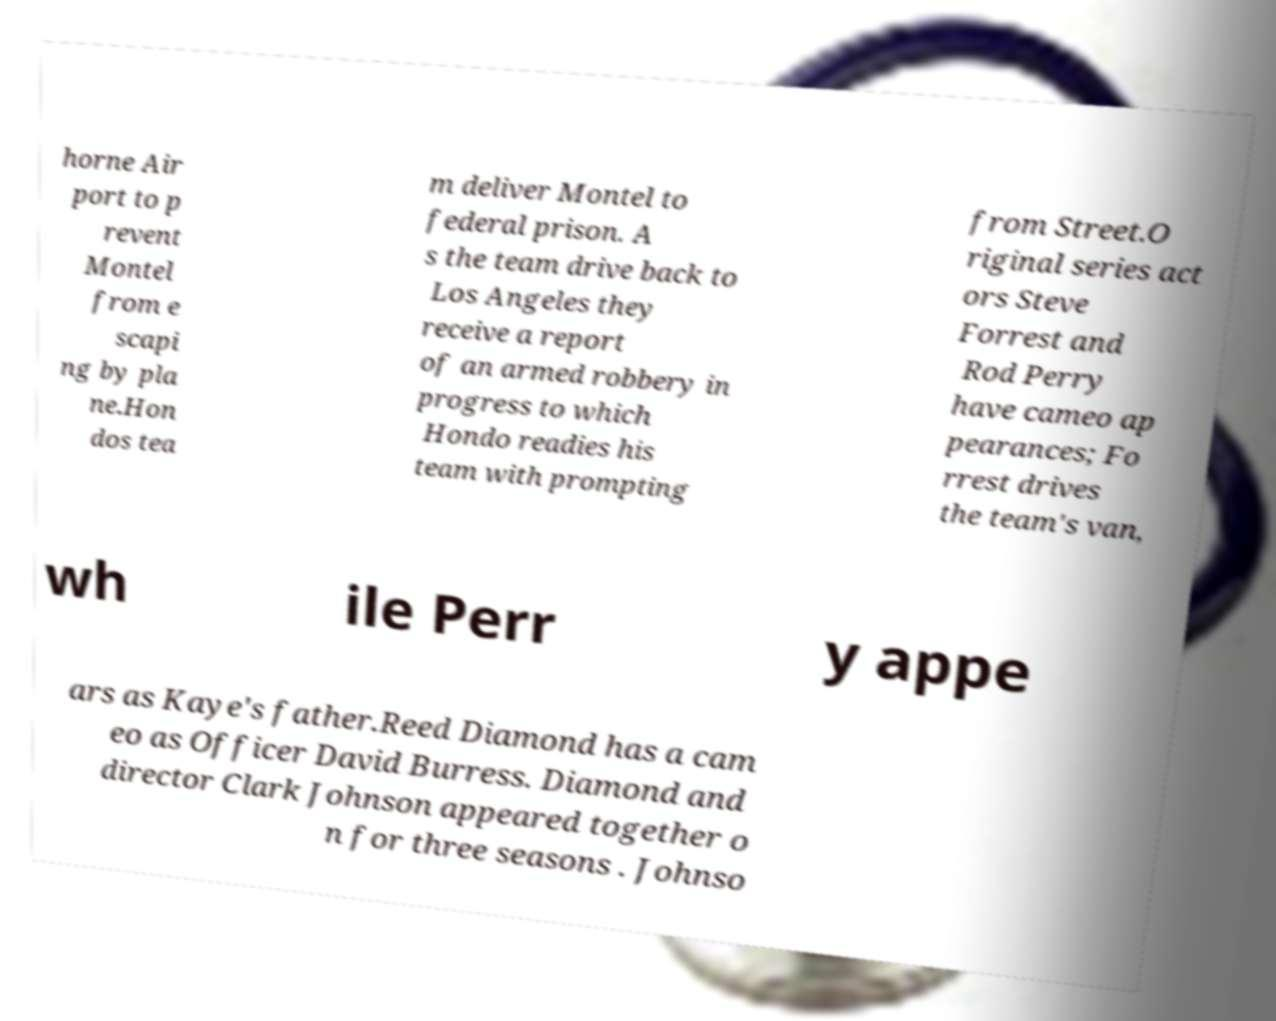What messages or text are displayed in this image? I need them in a readable, typed format. horne Air port to p revent Montel from e scapi ng by pla ne.Hon dos tea m deliver Montel to federal prison. A s the team drive back to Los Angeles they receive a report of an armed robbery in progress to which Hondo readies his team with prompting from Street.O riginal series act ors Steve Forrest and Rod Perry have cameo ap pearances; Fo rrest drives the team's van, wh ile Perr y appe ars as Kaye's father.Reed Diamond has a cam eo as Officer David Burress. Diamond and director Clark Johnson appeared together o n for three seasons . Johnso 